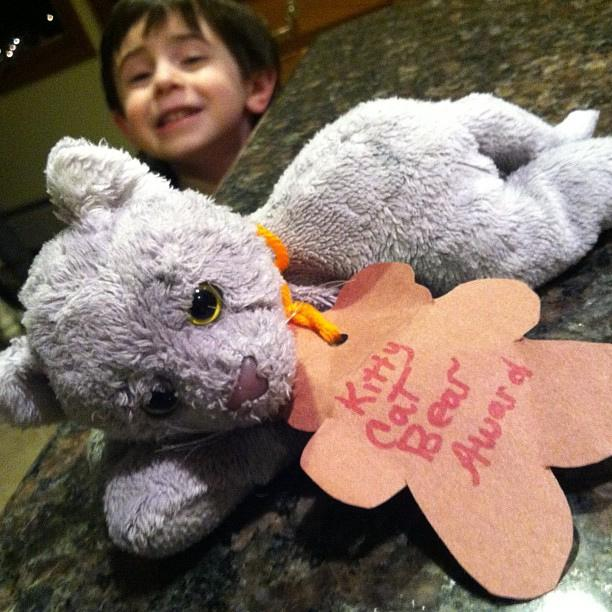What color is the twine wrapped around this little bear's neck?

Choices:
A) blue
B) purple
C) orange
D) red orange 